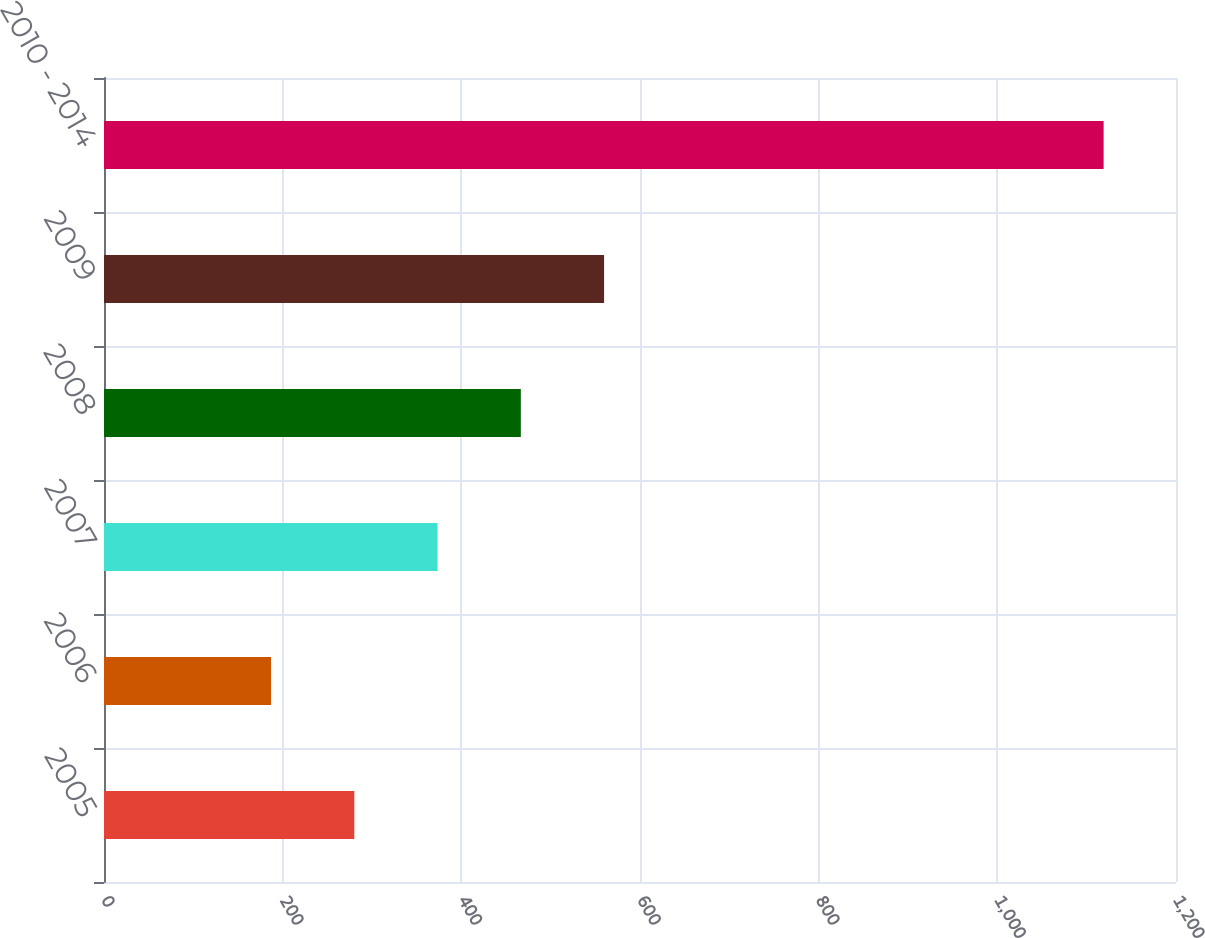<chart> <loc_0><loc_0><loc_500><loc_500><bar_chart><fcel>2005<fcel>2006<fcel>2007<fcel>2008<fcel>2009<fcel>2010 - 2014<nl><fcel>280.2<fcel>187<fcel>373.4<fcel>466.6<fcel>559.8<fcel>1119<nl></chart> 